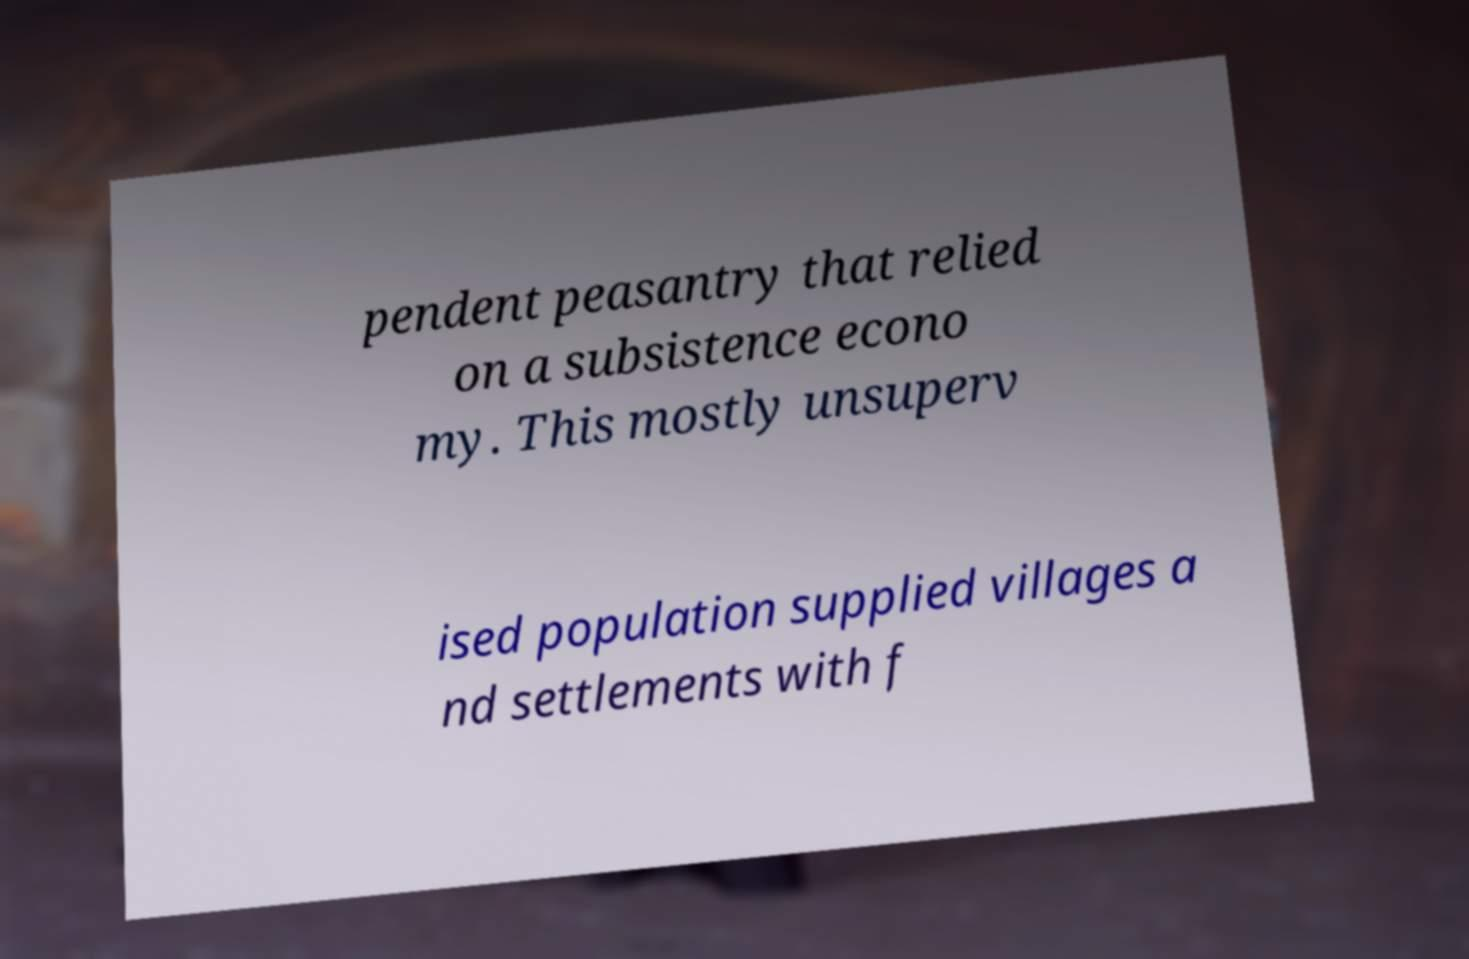There's text embedded in this image that I need extracted. Can you transcribe it verbatim? pendent peasantry that relied on a subsistence econo my. This mostly unsuperv ised population supplied villages a nd settlements with f 